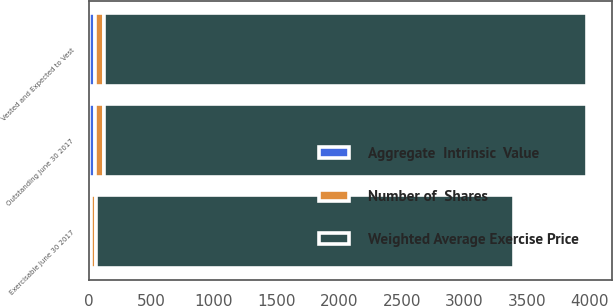Convert chart to OTSL. <chart><loc_0><loc_0><loc_500><loc_500><stacked_bar_chart><ecel><fcel>Outstanding June 30 2017<fcel>Vested and Expected to Vest<fcel>Exercisable June 30 2017<nl><fcel>Number of  Shares<fcel>72<fcel>72<fcel>40<nl><fcel>Aggregate  Intrinsic  Value<fcel>50.04<fcel>50.04<fcel>20.55<nl><fcel>Weighted Average Exercise Price<fcel>3859<fcel>3859<fcel>3333<nl></chart> 